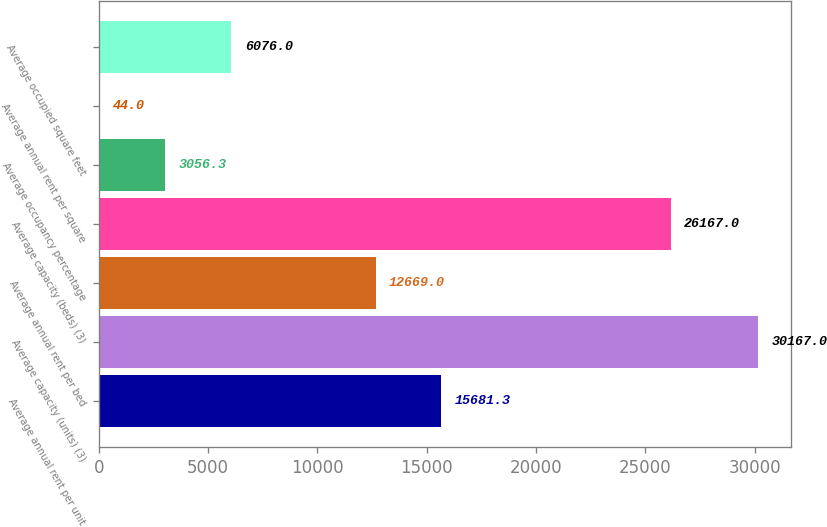<chart> <loc_0><loc_0><loc_500><loc_500><bar_chart><fcel>Average annual rent per unit<fcel>Average capacity (units) (3)<fcel>Average annual rent per bed<fcel>Average capacity (beds) (3)<fcel>Average occupancy percentage<fcel>Average annual rent per square<fcel>Average occupied square feet<nl><fcel>15681.3<fcel>30167<fcel>12669<fcel>26167<fcel>3056.3<fcel>44<fcel>6076<nl></chart> 